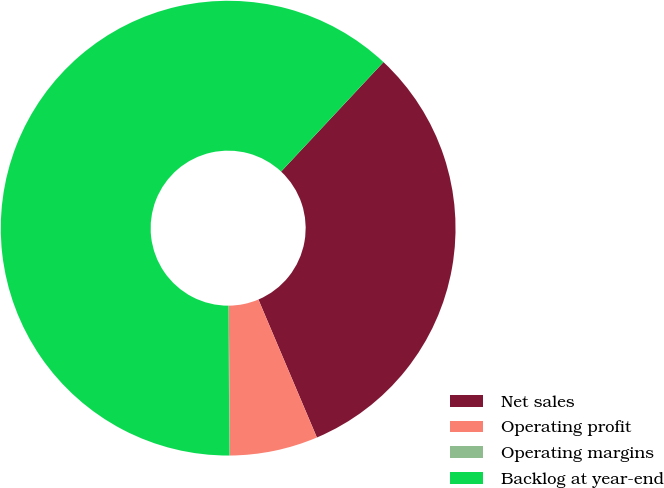Convert chart to OTSL. <chart><loc_0><loc_0><loc_500><loc_500><pie_chart><fcel>Net sales<fcel>Operating profit<fcel>Operating margins<fcel>Backlog at year-end<nl><fcel>31.65%<fcel>6.25%<fcel>0.05%<fcel>62.05%<nl></chart> 